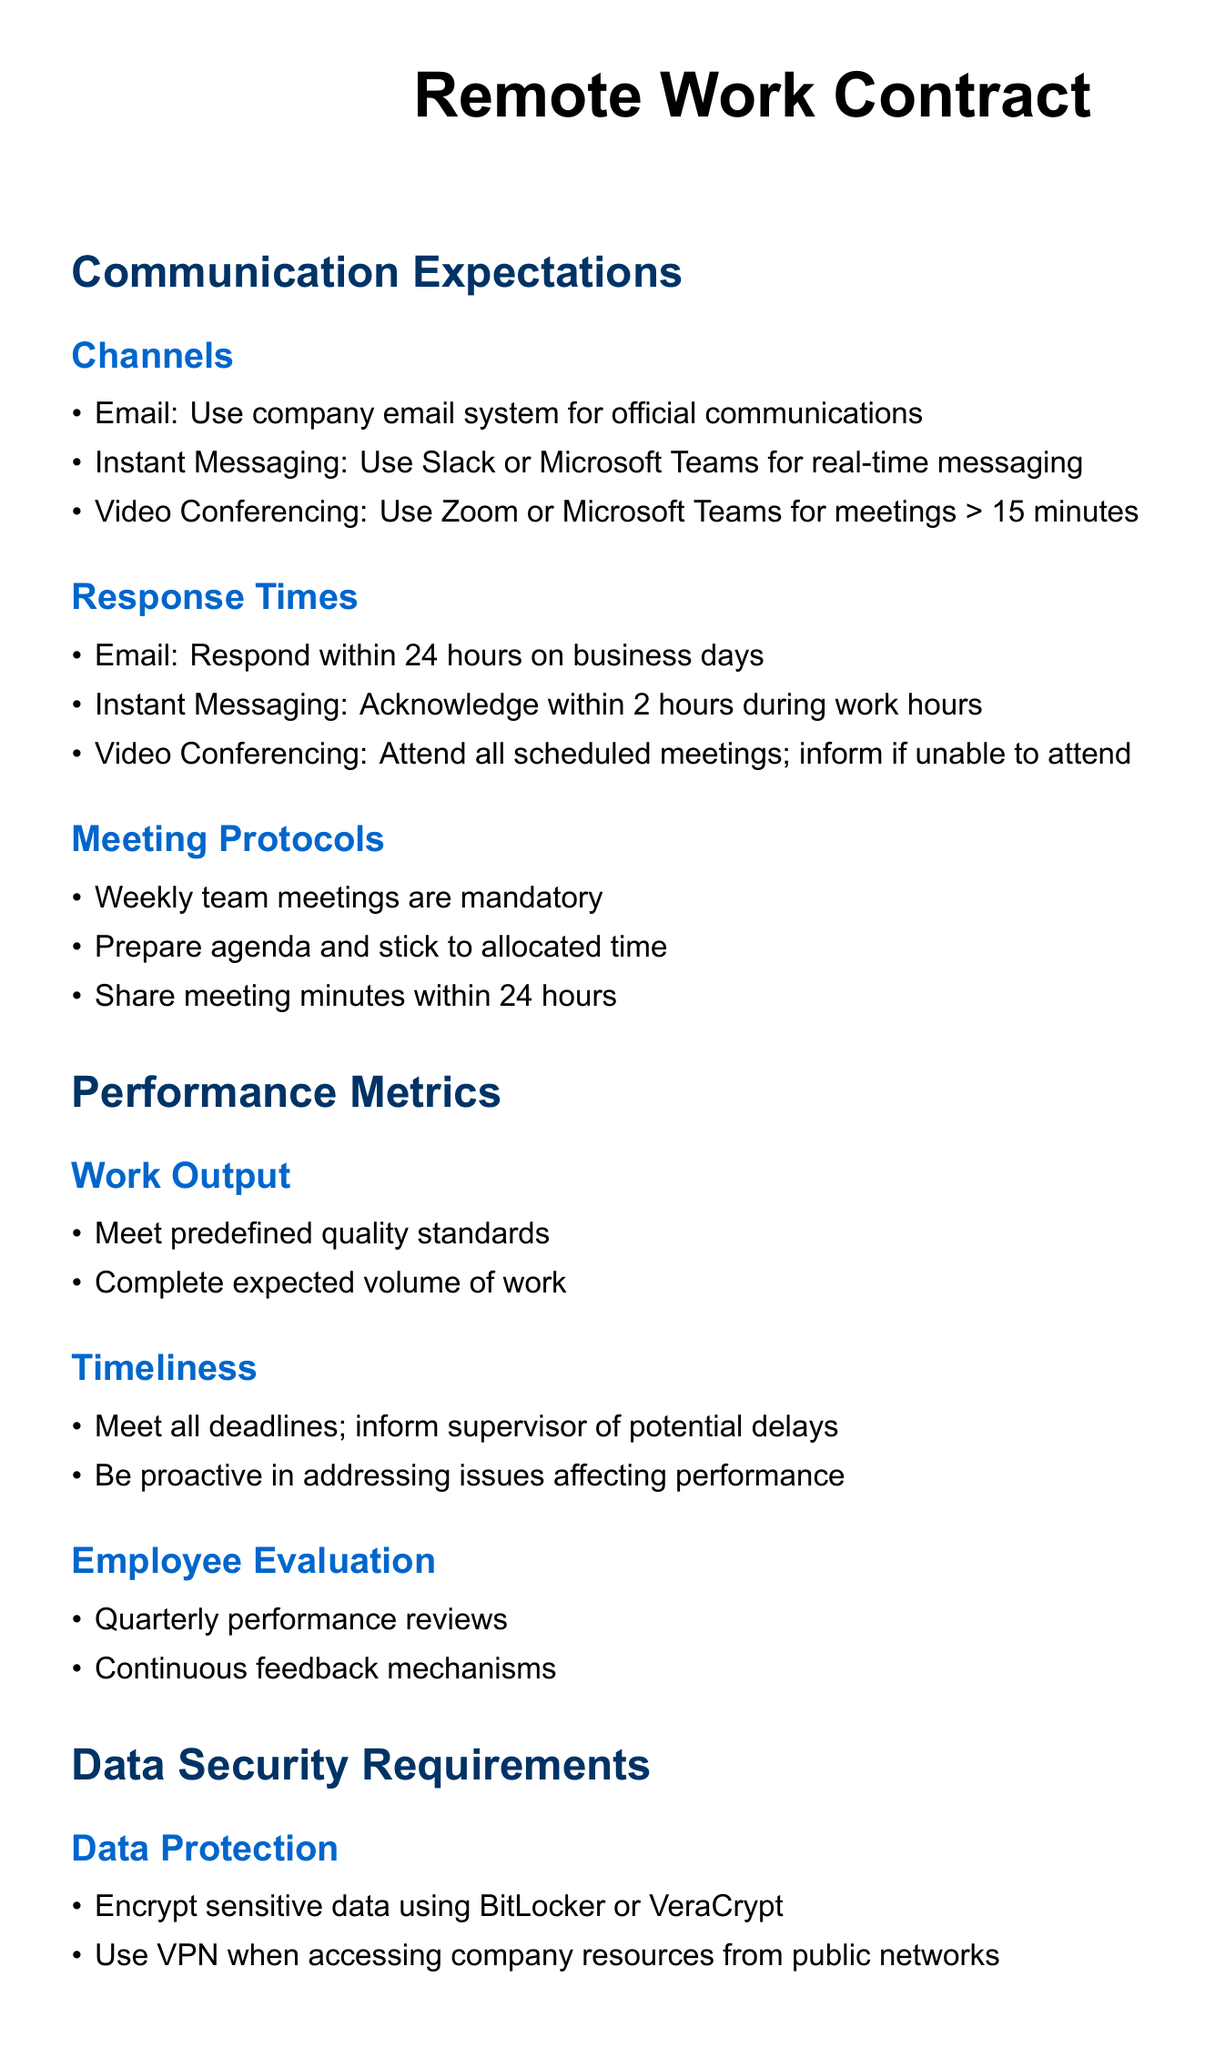What is the primary channel for official communications? The document specifies that the company email system should be used for official communications.
Answer: company email system What is the expected response time for emails? According to the document, employees should respond to emails within 24 hours on business days.
Answer: 24 hours How often are performance reviews conducted? The document states that performance reviews are to be conducted quarterly.
Answer: quarterly What must employees use when accessing company resources from public networks? The document requires the use of a VPN when accessing company resources from public networks.
Answer: VPN What is the minimum notice period for missing a scheduled meeting? Employees must inform if they are unable to attend a scheduled meeting.
Answer: inform What training must employees complete annually? The document outlines that employees must complete annual cybersecurity training.
Answer: annual cybersecurity training What tool is used for video conferencing meetings longer than 15 minutes? The document lists Zoom or Microsoft Teams as the tools for video conferencing meetings longer than 15 minutes.
Answer: Zoom or Microsoft Teams What must be shared within 24 hours after a meeting? The document states that meeting minutes should be shared within 24 hours after a meeting.
Answer: meeting minutes How should sensitive data be protected? The document mentions that sensitive data must be encrypted using BitLocker or VeraCrypt.
Answer: BitLocker or VeraCrypt 